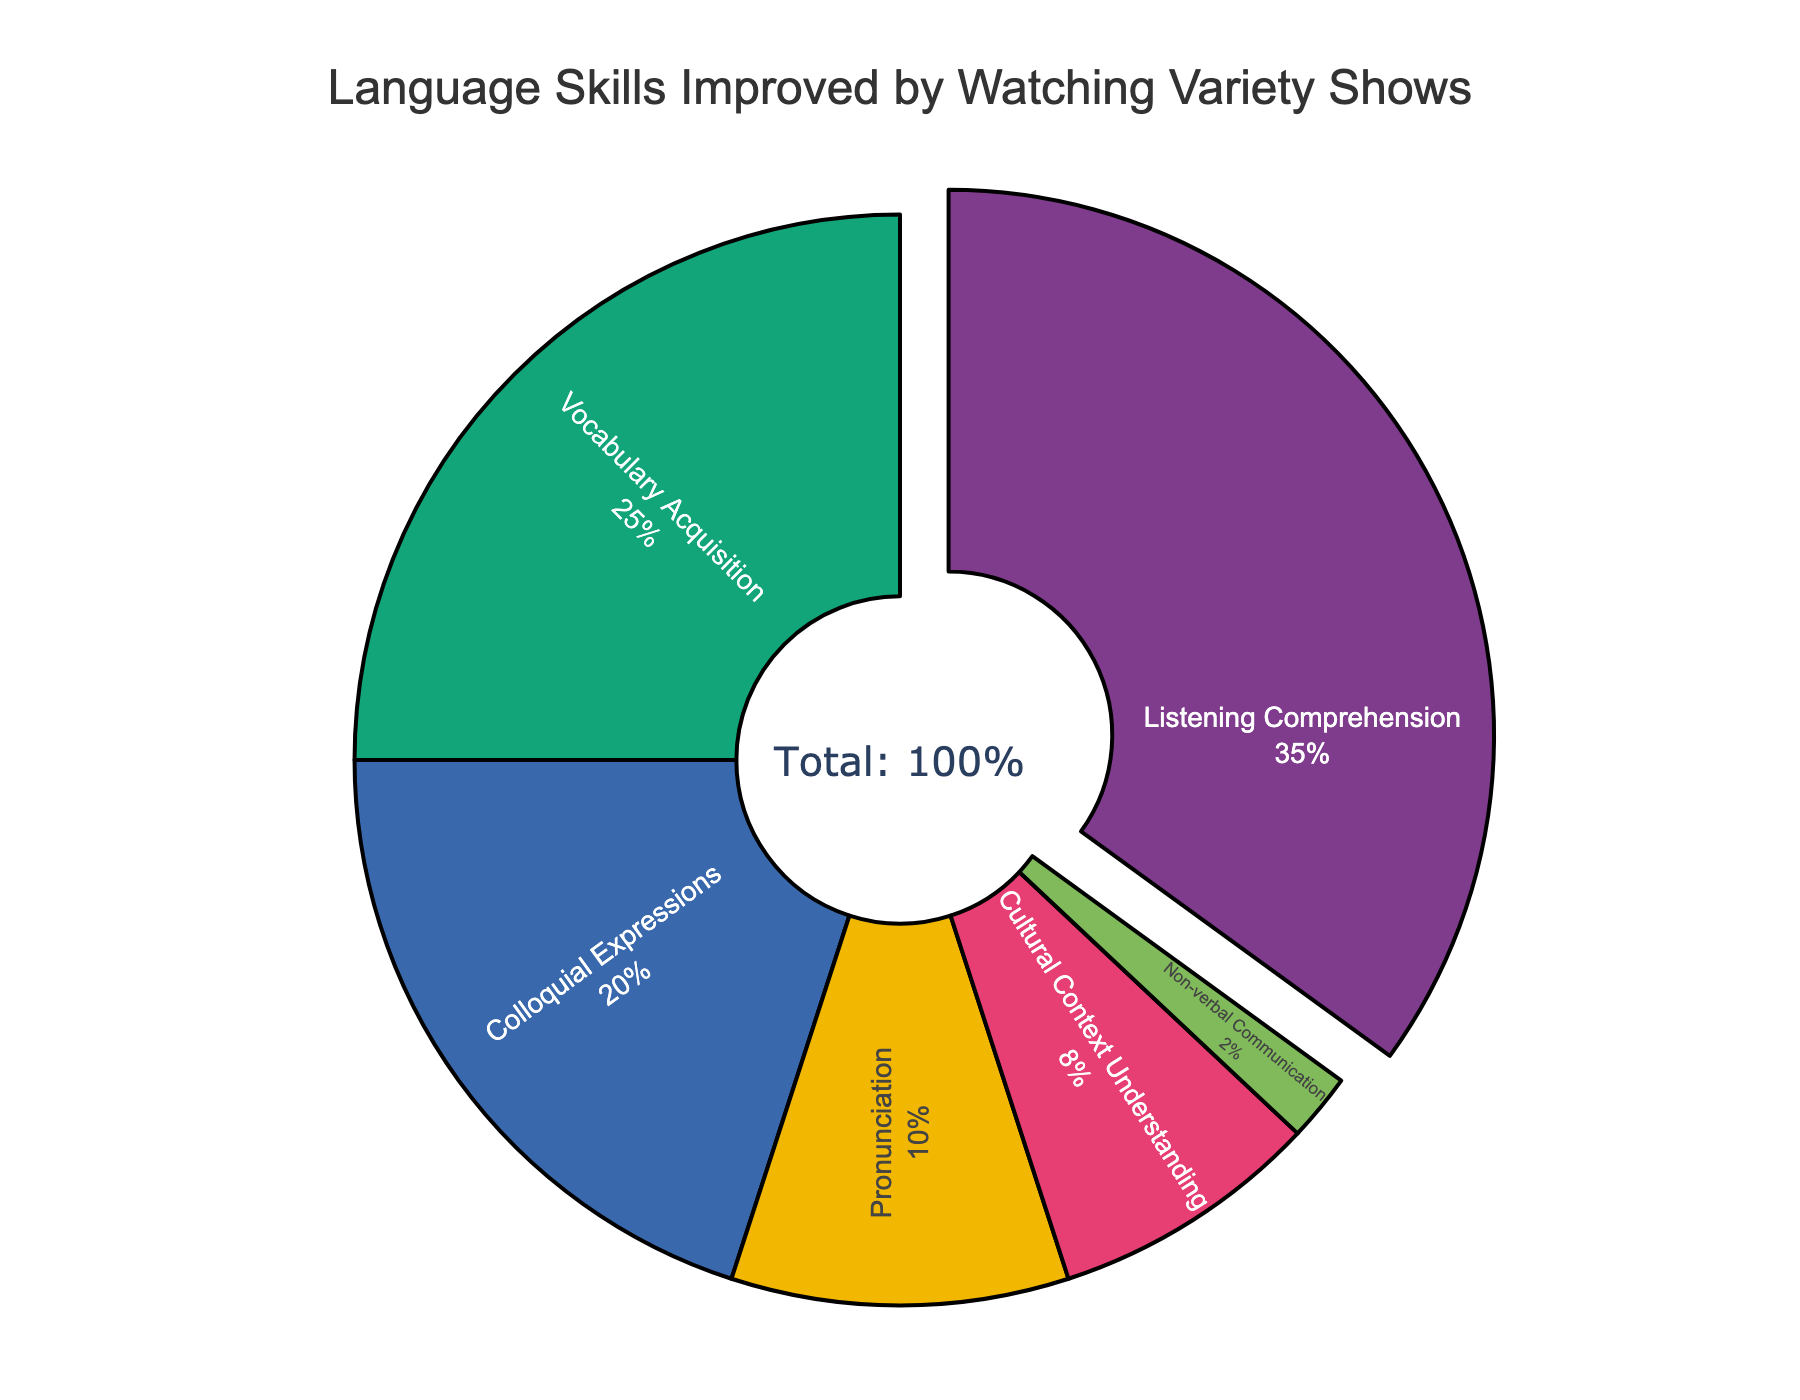What percentage of total language skills improved is achieved through listening comprehension and vocabulary acquisition combined? To find the combined percentage for listening comprehension and vocabulary acquisition, we need to sum both values. According to the figure, listening comprehension is 35% and vocabulary acquisition is 25%. So, 35 + 25 = 60%.
Answer: 60% Which language skill has the smallest percentage improvement? By examining the pie chart, the smallest segment correlates with non-verbal communication, which has a value of 2%.
Answer: Non-verbal Communication Among cultural context understanding and pronunciation, which has a higher percentage improvement, and by how much? To compare both values, we look at the figure: cultural context understanding has 8% and pronunciation has 10%. The difference is 10 - 8 = 2%. Therefore, pronunciation has a higher improvement by 2%.
Answer: Pronunciation, by 2% How does the percentage improvement in colloquial expressions compare to that in cultural context understanding? The figure indicates that colloquial expressions have 20% and cultural context understanding has 8%. Therefore, colloquial expressions have a greater percentage improvement.
Answer: Colloquial Expressions (greater) What is the average percentage improvement across all the language skills shown? The total percentage is 100%, and there are 6 categories. So, the average percentage is calculated as 100 / 6 ≈ 16.67%.
Answer: ≈ 16.67% What proportion of the total percentage represents the largest category? The largest segment is listening comprehension at 35%. To confirm the proportion, we divide 35 by the total 100. Therefore, the proportion is 35 / 100 = 0.35 or 35%.
Answer: 35% Is the improvement in pronunciation more or less than half of that in listening comprehension? Listening comprehension has 35% and pronunciation has 10%. Half of the listening comprehension value is 35 / 2 = 17.5%. Since 10% is less than 17.5%, the improvement in pronunciation is less.
Answer: Less 